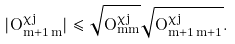Convert formula to latex. <formula><loc_0><loc_0><loc_500><loc_500>| O ^ { \chi j } _ { m + 1 \, m } | \leq \sqrt { O ^ { \chi j } _ { m m } } \sqrt { O ^ { \chi j } _ { m + 1 \, m + 1 } } .</formula> 